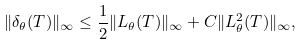Convert formula to latex. <formula><loc_0><loc_0><loc_500><loc_500>\| \delta _ { \theta } ( T ) \| _ { \infty } \leq \frac { 1 } { 2 } \| L _ { \theta } ( T ) \| _ { \infty } + C \| L _ { \theta } ^ { 2 } ( T ) \| _ { \infty } ,</formula> 